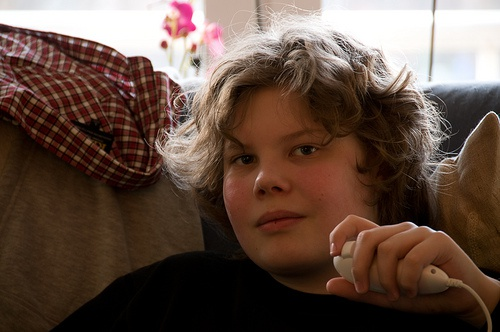Describe the objects in this image and their specific colors. I can see people in lightgray, black, maroon, and gray tones, couch in lightgray, black, gray, and maroon tones, and remote in lightgray, maroon, black, brown, and gray tones in this image. 